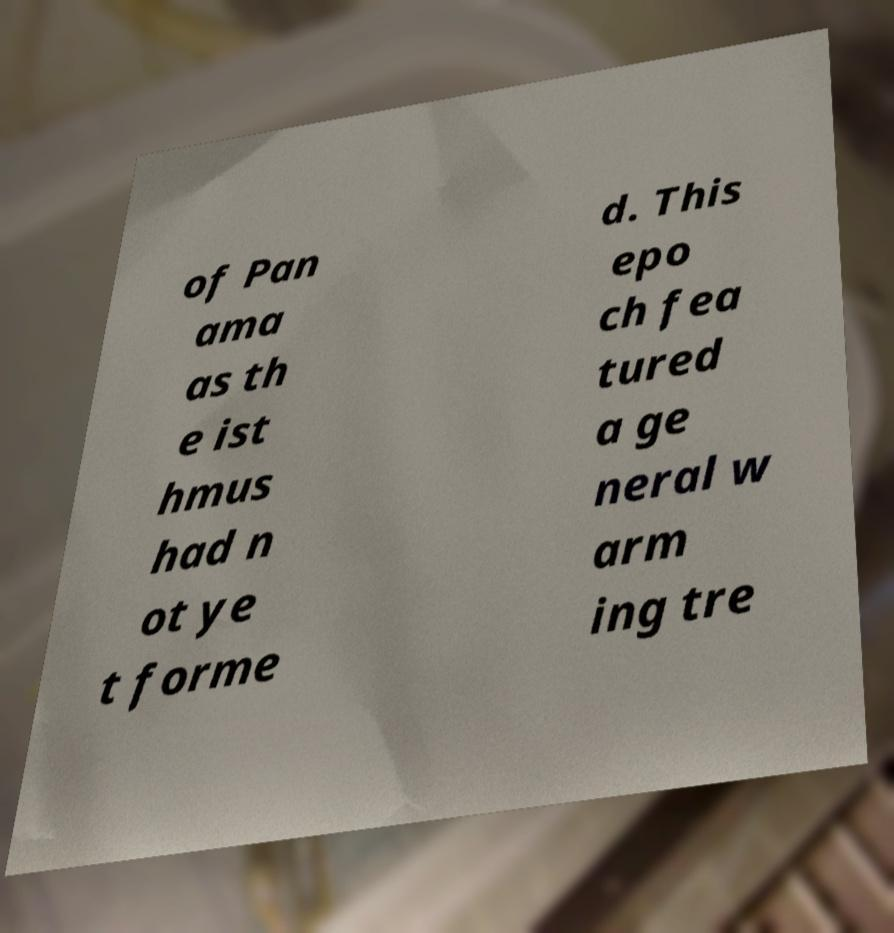What messages or text are displayed in this image? I need them in a readable, typed format. of Pan ama as th e ist hmus had n ot ye t forme d. This epo ch fea tured a ge neral w arm ing tre 